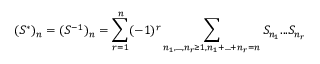<formula> <loc_0><loc_0><loc_500><loc_500>( S ^ { * } ) _ { n } = ( S ^ { - 1 } ) _ { n } = \sum _ { r = 1 } ^ { n } ( - 1 ) ^ { r } \sum _ { n _ { 1 } , \dots , n _ { r } \geq 1 , n _ { 1 } + \dots + n _ { r } = n } S _ { n _ { 1 } } \dots S _ { n _ { r } }</formula> 